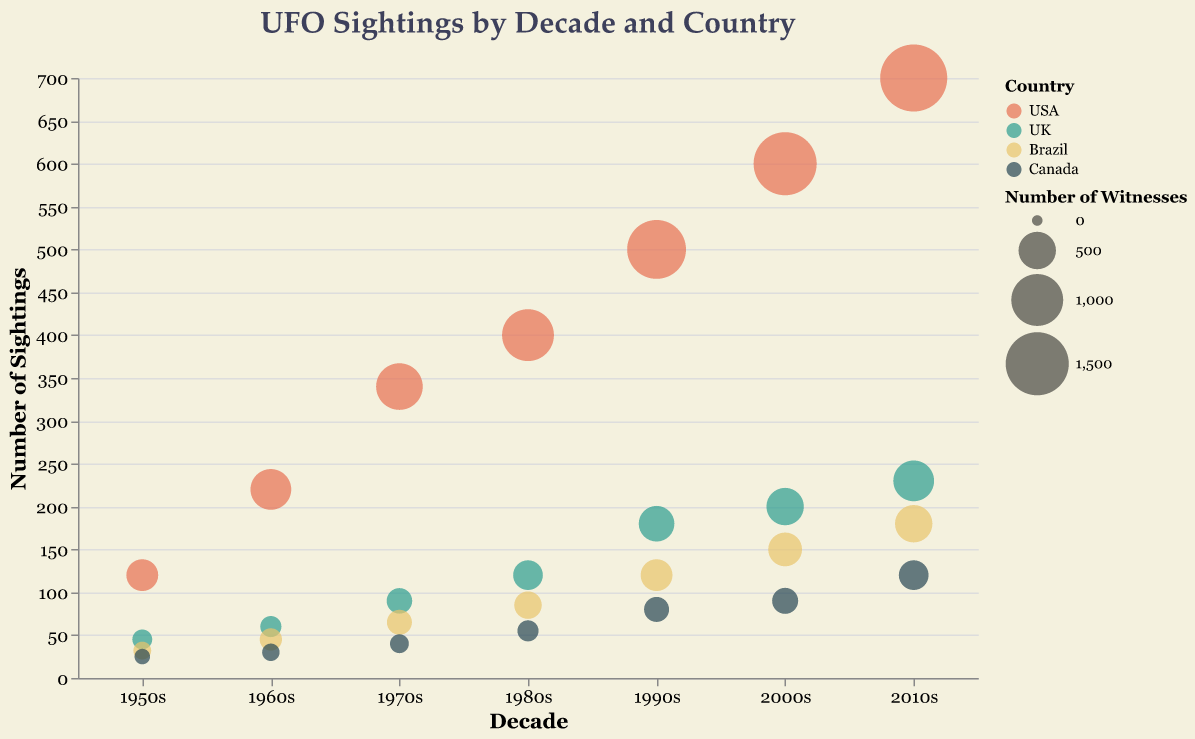What is the title of the chart? The title of the chart is located at the top center and describes the overall purpose of the visual. Here, it reads "UFO Sightings by Decade and Country".
Answer: UFO Sightings by Decade and Country Which country has the most UFO sightings in the 2010s? To determine this, look for the largest bubbles in the 2010s section on the x-axis. The size of the bubble represents the number of witnesses, and you should also consider the y-axis which indicates the number of sightings. The largest and highest bubble is from the USA.
Answer: USA How many sightings were reported in Canada during the 1980s? Locate the bubble for Canada in the 1980s section on the x-axis. The position on the y-axis shows the number of sightings. For Canada in the 1980s, the bubble is positioned at 55.
Answer: 55 Which decade shows the smallest number of UFO sightings for Brazil? To find this, compare the bubbles for Brazil across all decades. The smallest bubble, based on both the y-axis position (number of sightings) and the bubble size (number of witnesses), is in the 1950s.
Answer: 1950s Compare the number of sightings in the USA between the 1950s and the 2010s. Which decade had more sightings and by how much? First, identify the bubbles for the USA in the 1950s and the 2010s on the x-axis. Check their positions on the y-axis: the 1950s show 120 sightings, and the 2010s show 700 sightings. Subtract the smaller number from the larger number. 700 - 120 = 580.
Answer: 2010s had 580 more sightings Which country had the smallest number of witnesses in the 1990s? Look at the bubbles in the 1990s section on the x-axis for each country and compare their sizes. The bubble with the smallest size corresponds to Canada.
Answer: Canada How did the number of UFO sightings in the UK change from the 1960s to the 2000s? Track the bubbles for the UK from the 1960s to the 2000s along the x-axis and check their y-axis positions: The UK had 60 sightings in the 1960s and 200 sightings in the 2000s. The number of sightings increased by 140.
Answer: Increased by 140 What is the average number of sightings for Brazil during the 1990s and 2000s? Locate the bubbles for Brazil in the 1990s and 2000s on the x-axis, check their y-axis positions: 120 in the 1990s and 150 in the 2000s. To find the average, add these numbers and divide by 2. (120 + 150) / 2 = 135.
Answer: 135 In which country did the number of witnesses exceed 1000 first, and in what decade? Look for the first instance where any country's bubble size exceeds 1000 witnesses. The USA's bubble in the 1980s is the first to exceed this threshold, with 1000 witnesses.
Answer: USA in the 1980s Is there a decade where the number of witnesses in Canada equals the number of sightings in the UK? If yes, which decade and how many? Compare the number of witnesses for Canada with the number of sightings for the UK in each decade. In the 1960s, both Canada and the UK reported 30 sightings/witnesses, respectively.
Answer: 1960s, 30 